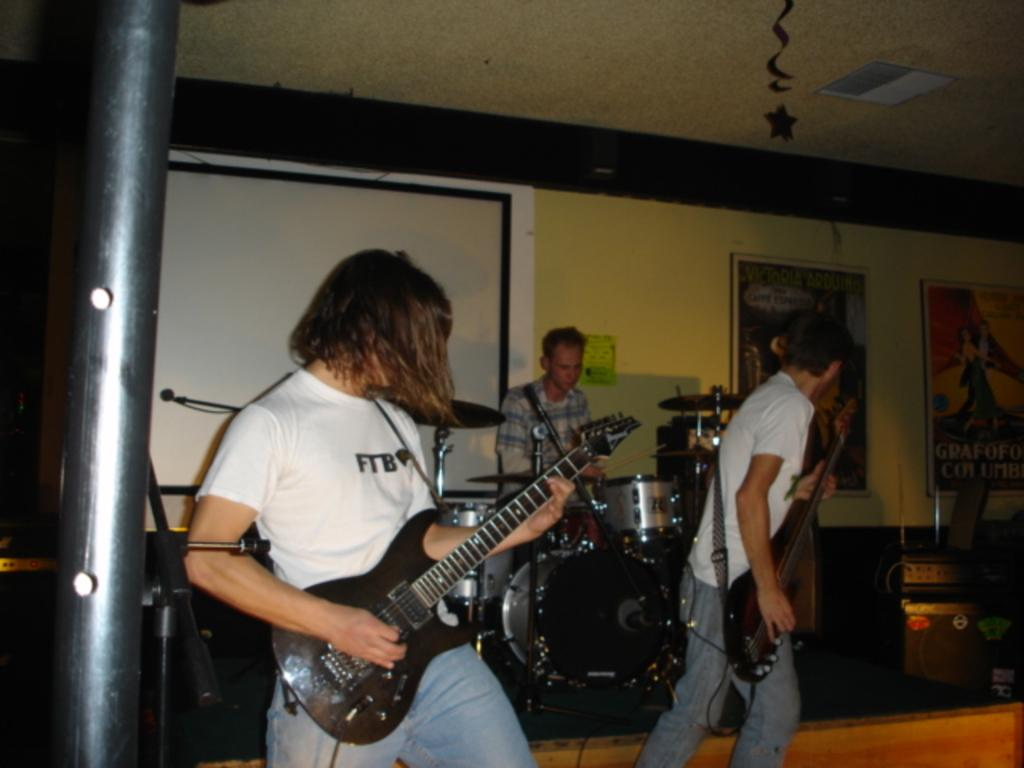What are the people in the image doing? The people in the image are holding guitars. Can you describe the man's activity in the image? The man is sitting and playing a drum set. How many people are holding musical instruments in the image? There are at least two people holding guitars in the image. What type of popcorn is being served in the image? There is no popcorn present in the image. Can you describe the horn that is being played in the image? There is no horn present in the image; the people are holding guitars and the man is playing a drum set. 